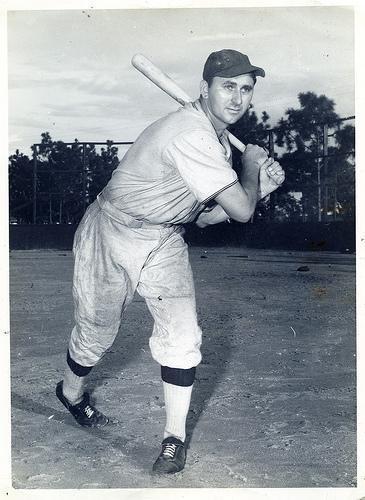How many people are in the picture?
Give a very brief answer. 1. How many shoes is the man wearing?
Give a very brief answer. 2. 